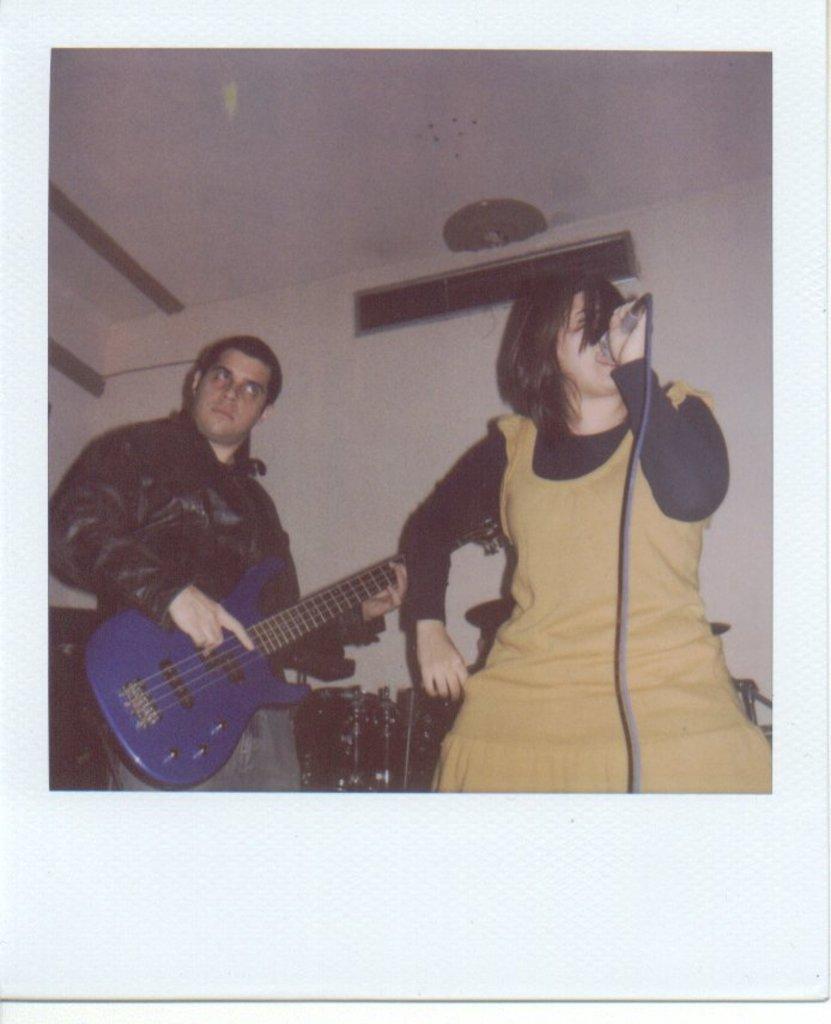Describe this image in one or two sentences. In this image there are two persons at the left side of the image there is a person playing guitar at the right side of the image there is a person holding microphone in her hand. 